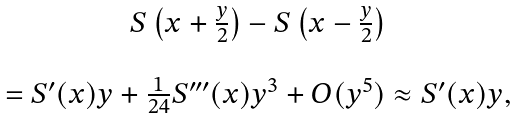Convert formula to latex. <formula><loc_0><loc_0><loc_500><loc_500>\begin{array} { c } S \left ( x + \frac { y } { 2 } \right ) - S \left ( x - \frac { y } { 2 } \right ) \\ \\ = S ^ { \prime } ( x ) y + \frac { 1 } { 2 4 } S ^ { \prime \prime \prime } ( x ) y ^ { 3 } + O ( y ^ { 5 } ) \approx S ^ { \prime } ( x ) y , \end{array}</formula> 